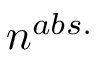<formula> <loc_0><loc_0><loc_500><loc_500>n ^ { a b s . }</formula> 